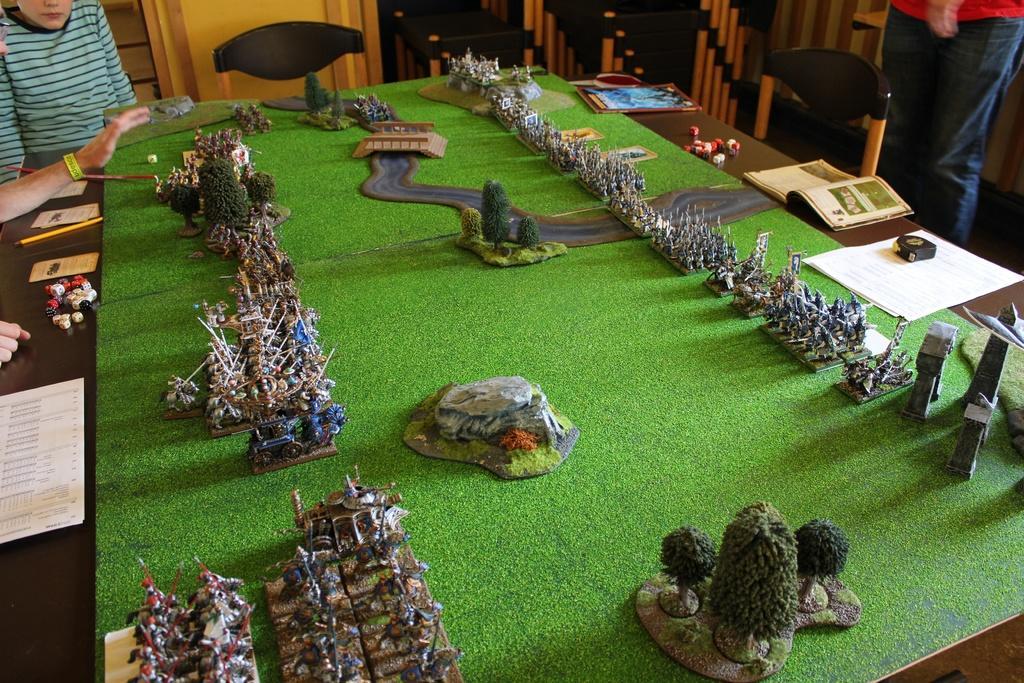Could you give a brief overview of what you see in this image? The picture is taken inside a closed room where one table is present. On that table one miniature of houses, park and trees are present and there are books and papers on the table and at the right corner one man is standing and at the left corner two people are sitting. 